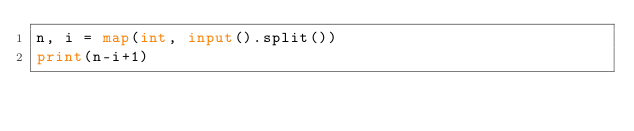Convert code to text. <code><loc_0><loc_0><loc_500><loc_500><_Python_>n, i = map(int, input().split())
print(n-i+1)</code> 